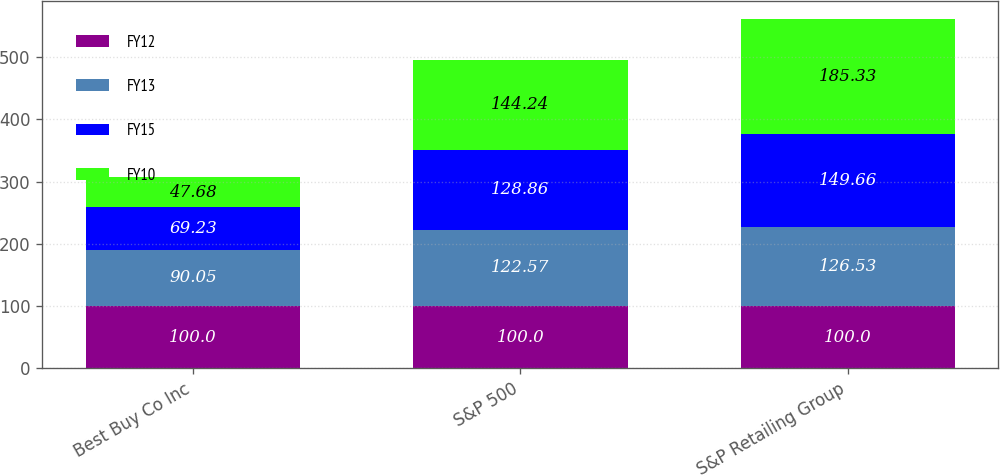Convert chart to OTSL. <chart><loc_0><loc_0><loc_500><loc_500><stacked_bar_chart><ecel><fcel>Best Buy Co Inc<fcel>S&P 500<fcel>S&P Retailing Group<nl><fcel>FY12<fcel>100<fcel>100<fcel>100<nl><fcel>FY13<fcel>90.05<fcel>122.57<fcel>126.53<nl><fcel>FY15<fcel>69.23<fcel>128.86<fcel>149.66<nl><fcel>FY10<fcel>47.68<fcel>144.24<fcel>185.33<nl></chart> 